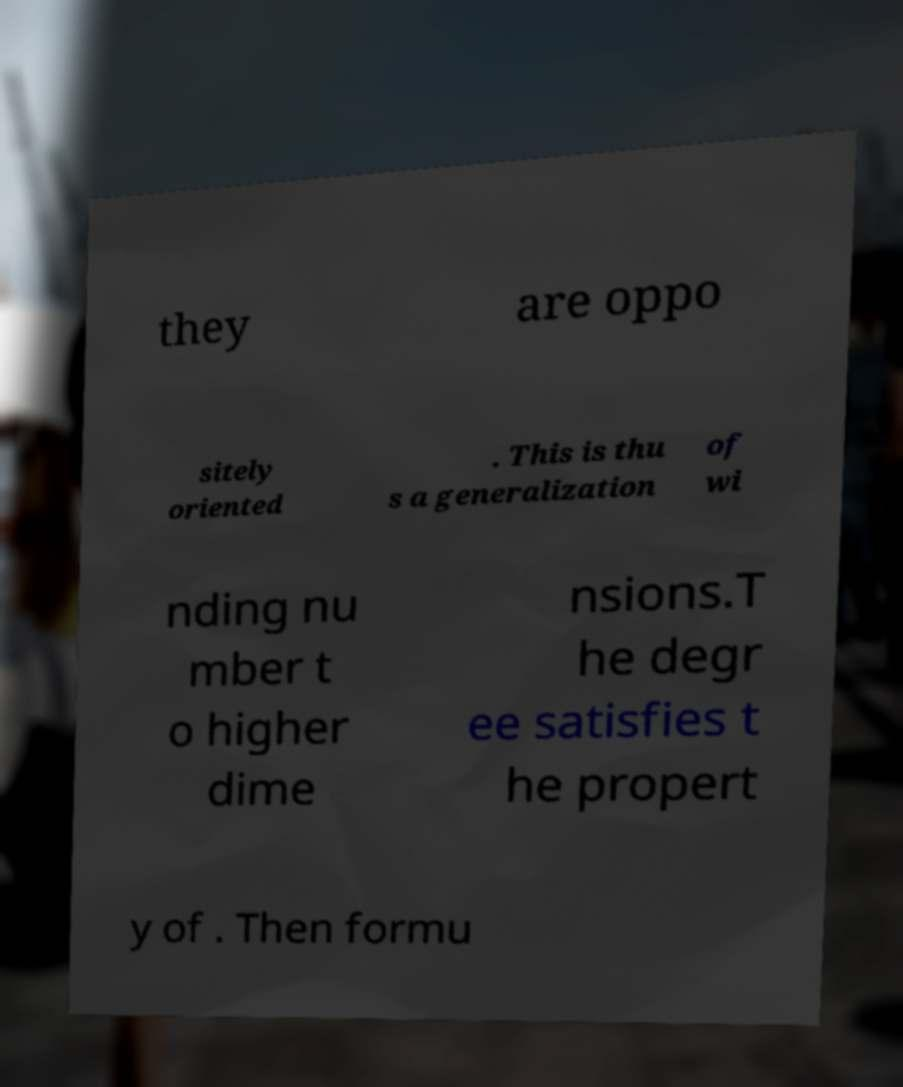Please identify and transcribe the text found in this image. they are oppo sitely oriented . This is thu s a generalization of wi nding nu mber t o higher dime nsions.T he degr ee satisfies t he propert y of . Then formu 